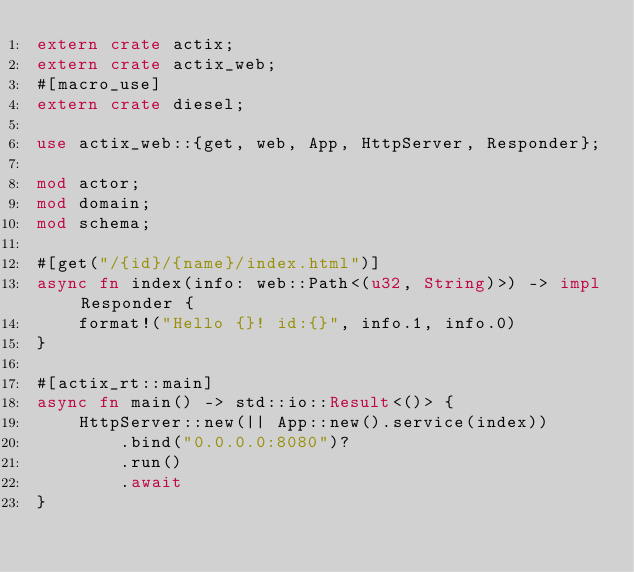<code> <loc_0><loc_0><loc_500><loc_500><_Rust_>extern crate actix;
extern crate actix_web;
#[macro_use]
extern crate diesel;

use actix_web::{get, web, App, HttpServer, Responder};

mod actor;
mod domain;
mod schema;

#[get("/{id}/{name}/index.html")]
async fn index(info: web::Path<(u32, String)>) -> impl Responder {
    format!("Hello {}! id:{}", info.1, info.0)
}

#[actix_rt::main]
async fn main() -> std::io::Result<()> {
    HttpServer::new(|| App::new().service(index))
        .bind("0.0.0.0:8080")?
        .run()
        .await
}
</code> 